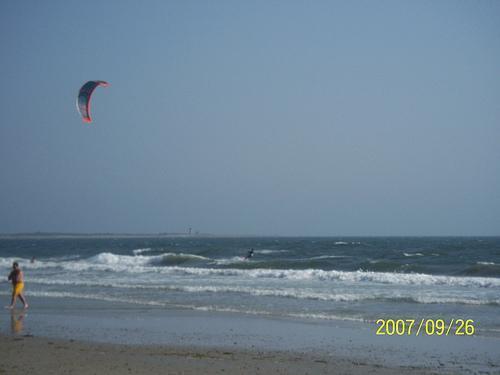How many people are there?
Give a very brief answer. 2. 